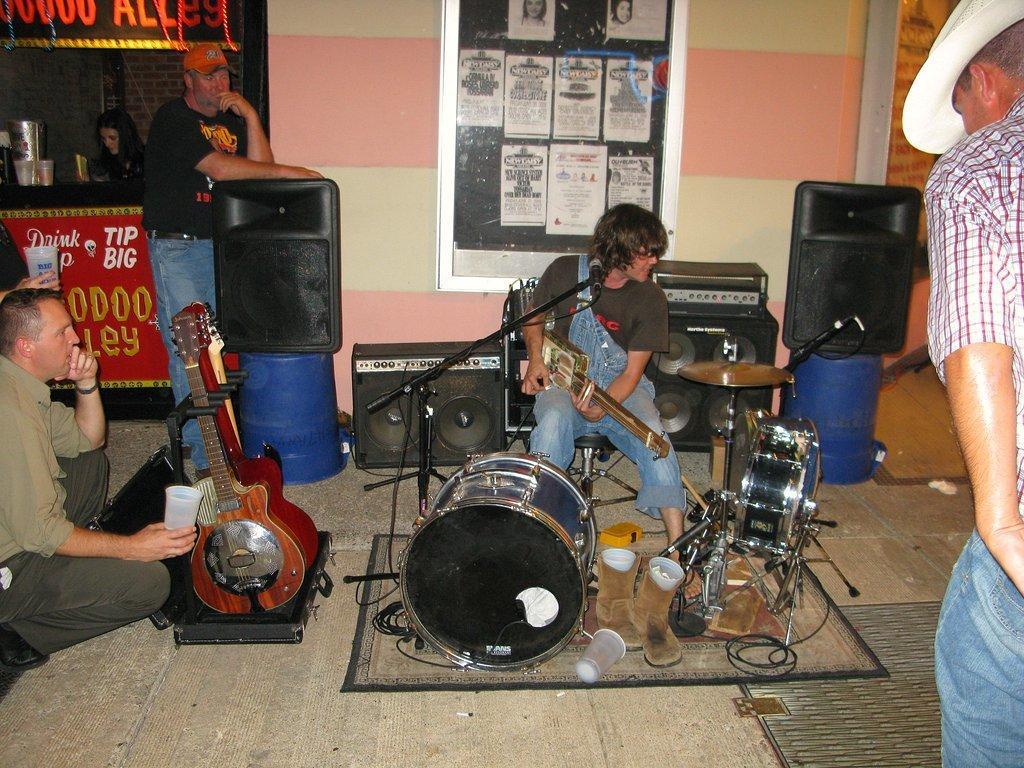Please provide a concise description of this image. In this picture we can see a person is playing musical instruments, behind we can see some speakers and board to the wall, some people are watching, one woman is near the tea stall. 